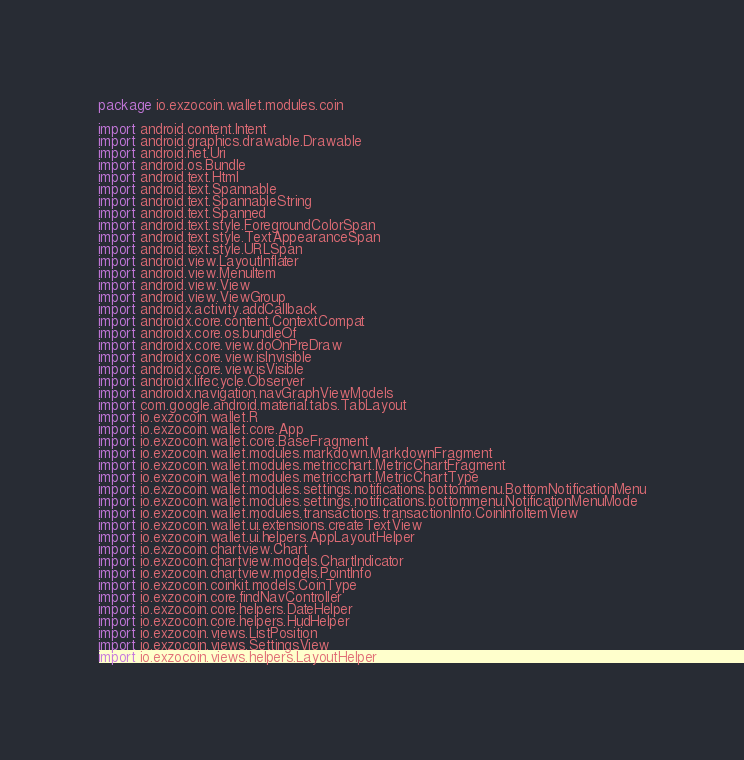Convert code to text. <code><loc_0><loc_0><loc_500><loc_500><_Kotlin_>package io.exzocoin.wallet.modules.coin

import android.content.Intent
import android.graphics.drawable.Drawable
import android.net.Uri
import android.os.Bundle
import android.text.Html
import android.text.Spannable
import android.text.SpannableString
import android.text.Spanned
import android.text.style.ForegroundColorSpan
import android.text.style.TextAppearanceSpan
import android.text.style.URLSpan
import android.view.LayoutInflater
import android.view.MenuItem
import android.view.View
import android.view.ViewGroup
import androidx.activity.addCallback
import androidx.core.content.ContextCompat
import androidx.core.os.bundleOf
import androidx.core.view.doOnPreDraw
import androidx.core.view.isInvisible
import androidx.core.view.isVisible
import androidx.lifecycle.Observer
import androidx.navigation.navGraphViewModels
import com.google.android.material.tabs.TabLayout
import io.exzocoin.wallet.R
import io.exzocoin.wallet.core.App
import io.exzocoin.wallet.core.BaseFragment
import io.exzocoin.wallet.modules.markdown.MarkdownFragment
import io.exzocoin.wallet.modules.metricchart.MetricChartFragment
import io.exzocoin.wallet.modules.metricchart.MetricChartType
import io.exzocoin.wallet.modules.settings.notifications.bottommenu.BottomNotificationMenu
import io.exzocoin.wallet.modules.settings.notifications.bottommenu.NotificationMenuMode
import io.exzocoin.wallet.modules.transactions.transactionInfo.CoinInfoItemView
import io.exzocoin.wallet.ui.extensions.createTextView
import io.exzocoin.wallet.ui.helpers.AppLayoutHelper
import io.exzocoin.chartview.Chart
import io.exzocoin.chartview.models.ChartIndicator
import io.exzocoin.chartview.models.PointInfo
import io.exzocoin.coinkit.models.CoinType
import io.exzocoin.core.findNavController
import io.exzocoin.core.helpers.DateHelper
import io.exzocoin.core.helpers.HudHelper
import io.exzocoin.views.ListPosition
import io.exzocoin.views.SettingsView
import io.exzocoin.views.helpers.LayoutHelper</code> 